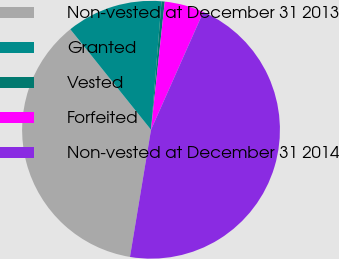Convert chart to OTSL. <chart><loc_0><loc_0><loc_500><loc_500><pie_chart><fcel>Non-vested at December 31 2013<fcel>Granted<fcel>Vested<fcel>Forfeited<fcel>Non-vested at December 31 2014<nl><fcel>36.62%<fcel>12.07%<fcel>0.4%<fcel>4.95%<fcel>45.96%<nl></chart> 